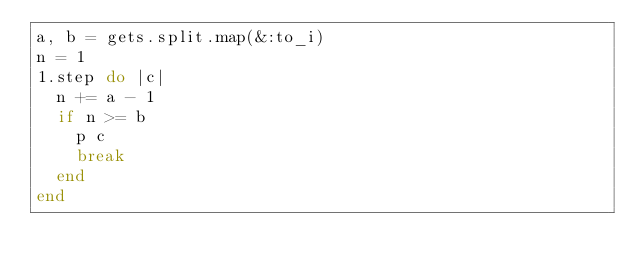<code> <loc_0><loc_0><loc_500><loc_500><_Ruby_>a, b = gets.split.map(&:to_i)
n = 1
1.step do |c|
  n += a - 1
  if n >= b
    p c
    break
  end
end
</code> 